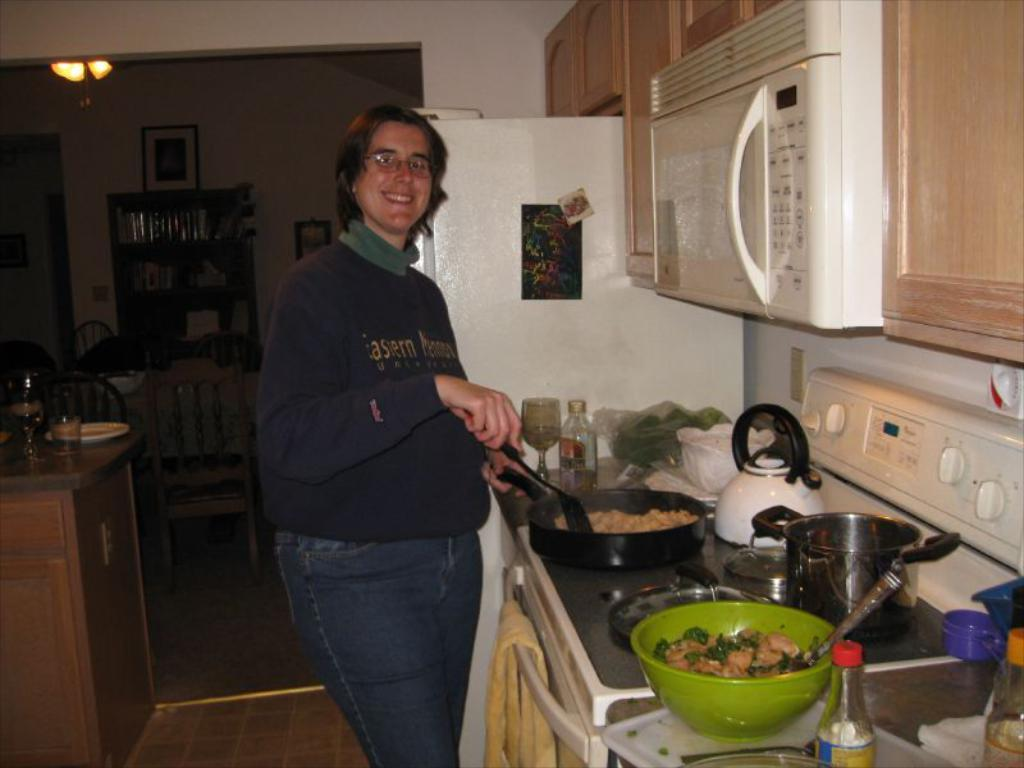<image>
Summarize the visual content of the image. A woman cooking food in her kitchen, wearing a shirt saying Eastern... University. 